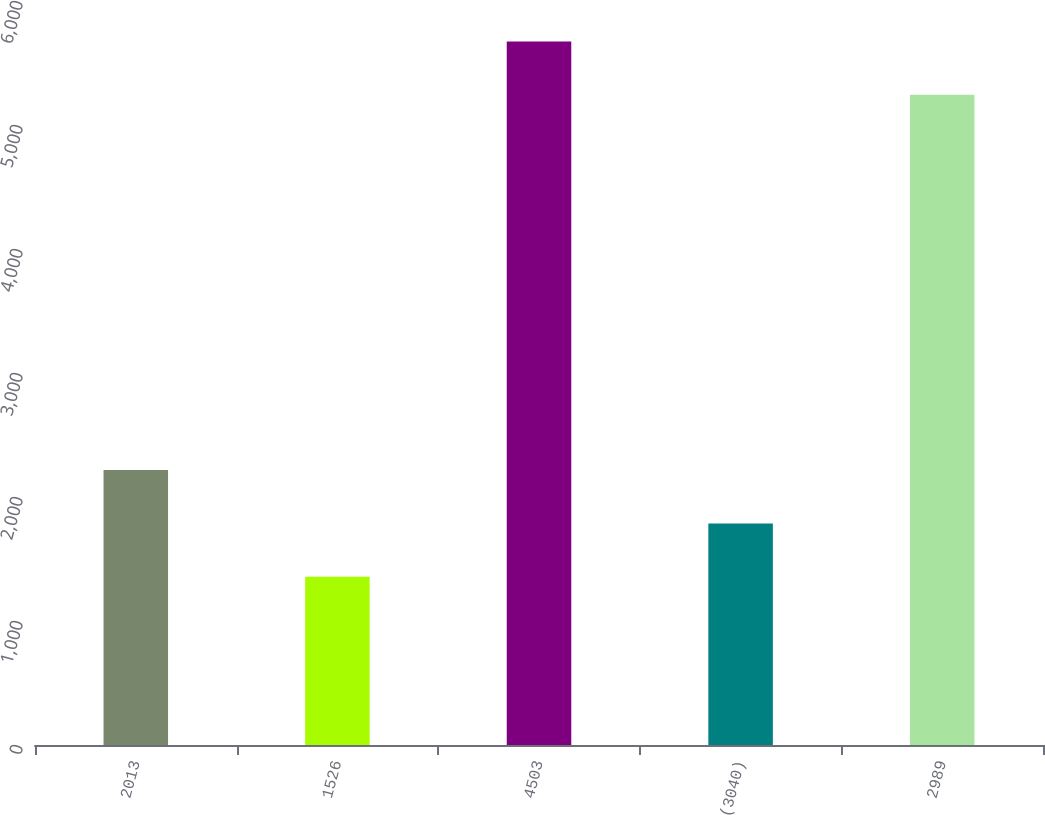Convert chart. <chart><loc_0><loc_0><loc_500><loc_500><bar_chart><fcel>2013<fcel>1526<fcel>4503<fcel>(3040)<fcel>2989<nl><fcel>2216.8<fcel>1357<fcel>5672.9<fcel>1786.9<fcel>5243<nl></chart> 